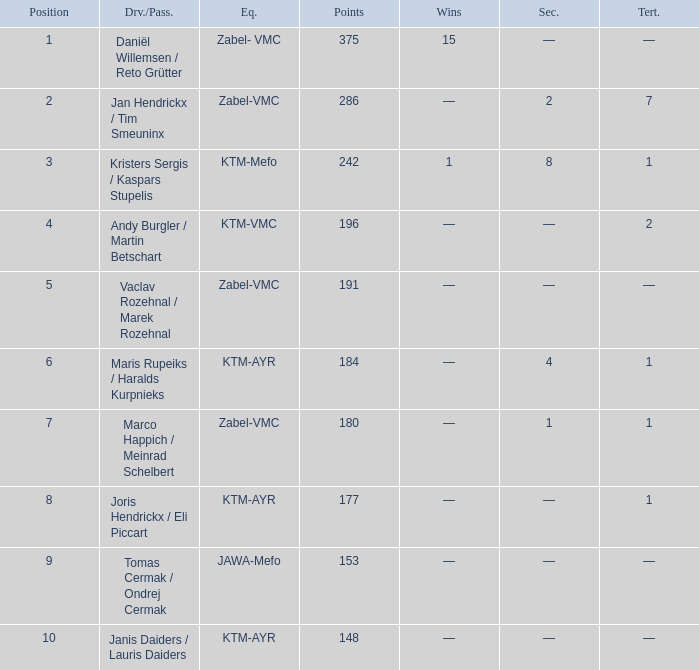Who was the driver/passengar when the position was smaller than 8, the third was 1, and there was 1 win? Kristers Sergis / Kaspars Stupelis. 